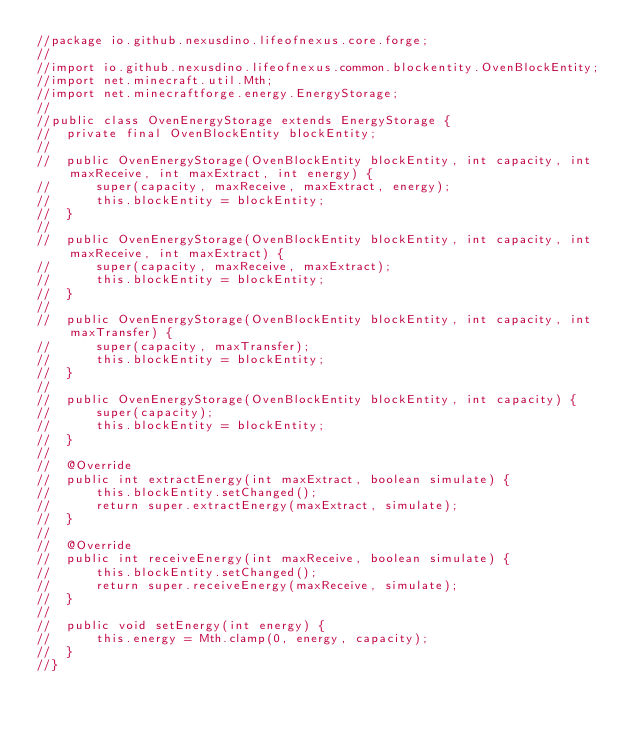Convert code to text. <code><loc_0><loc_0><loc_500><loc_500><_Java_>//package io.github.nexusdino.lifeofnexus.core.forge;
//
//import io.github.nexusdino.lifeofnexus.common.blockentity.OvenBlockEntity;
//import net.minecraft.util.Mth;
//import net.minecraftforge.energy.EnergyStorage;
//
//public class OvenEnergyStorage extends EnergyStorage {
//	private final OvenBlockEntity blockEntity;
//
//	public OvenEnergyStorage(OvenBlockEntity blockEntity, int capacity, int maxReceive, int maxExtract, int energy) {
//		super(capacity, maxReceive, maxExtract, energy);
//		this.blockEntity = blockEntity;
//	}
//
//	public OvenEnergyStorage(OvenBlockEntity blockEntity, int capacity, int maxReceive, int maxExtract) {
//		super(capacity, maxReceive, maxExtract);
//		this.blockEntity = blockEntity;
//	}
//
//	public OvenEnergyStorage(OvenBlockEntity blockEntity, int capacity, int maxTransfer) {
//		super(capacity, maxTransfer);
//		this.blockEntity = blockEntity;
//	}
//
//	public OvenEnergyStorage(OvenBlockEntity blockEntity, int capacity) {
//		super(capacity);
//		this.blockEntity = blockEntity;
//	}
//
//	@Override
//	public int extractEnergy(int maxExtract, boolean simulate) {
//		this.blockEntity.setChanged();
//		return super.extractEnergy(maxExtract, simulate);
//	}
//
//	@Override
//	public int receiveEnergy(int maxReceive, boolean simulate) {
//		this.blockEntity.setChanged();
//		return super.receiveEnergy(maxReceive, simulate);
//	}
//	
//	public void setEnergy(int energy) {
//		this.energy = Mth.clamp(0, energy, capacity);
//	}
//}
</code> 